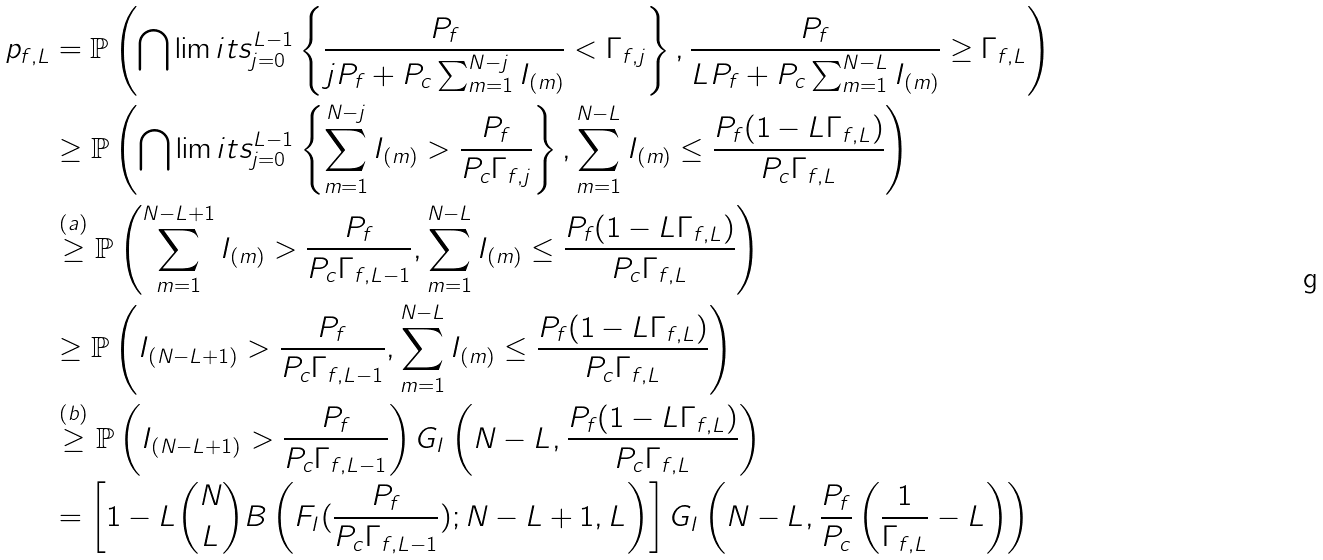Convert formula to latex. <formula><loc_0><loc_0><loc_500><loc_500>p _ { f , L } & = \mathbb { P } \left ( \bigcap \lim i t s _ { j = 0 } ^ { L - 1 } \left \{ \frac { P _ { f } } { j P _ { f } + P _ { c } \sum _ { m = 1 } ^ { N - j } I _ { ( m ) } } < \Gamma _ { f , j } \right \} , \frac { P _ { f } } { L P _ { f } + P _ { c } \sum _ { m = 1 } ^ { N - L } I _ { ( m ) } } \geq \Gamma _ { f , L } \right ) \\ & \geq \mathbb { P } \left ( \bigcap \lim i t s _ { j = 0 } ^ { L - 1 } \left \{ \sum _ { m = 1 } ^ { N - j } I _ { ( m ) } > \frac { P _ { f } } { P _ { c } \Gamma _ { f , j } } \right \} , \sum _ { m = 1 } ^ { N - L } I _ { ( m ) } \leq \frac { P _ { f } ( 1 - L \Gamma _ { f , L } ) } { P _ { c } \Gamma _ { f , L } } \right ) \\ & \stackrel { ( a ) } { \geq } \mathbb { P } \left ( \sum _ { m = 1 } ^ { N - L + 1 } I _ { ( m ) } > \frac { P _ { f } } { P _ { c } \Gamma _ { f , L - 1 } } , \sum _ { m = 1 } ^ { N - L } I _ { ( m ) } \leq \frac { P _ { f } ( 1 - L \Gamma _ { f , L } ) } { P _ { c } \Gamma _ { f , L } } \right ) \\ & \geq \mathbb { P } \left ( I _ { ( N - L + 1 ) } > \frac { P _ { f } } { P _ { c } \Gamma _ { f , L - 1 } } , \sum _ { m = 1 } ^ { N - L } I _ { ( m ) } \leq \frac { P _ { f } ( 1 - L \Gamma _ { f , L } ) } { P _ { c } \Gamma _ { f , L } } \right ) \\ & \stackrel { ( b ) } { \geq } \mathbb { P } \left ( I _ { ( N - L + 1 ) } > \frac { P _ { f } } { P _ { c } \Gamma _ { f , L - 1 } } \right ) G _ { I } \left ( N - L , \frac { P _ { f } ( 1 - L \Gamma _ { f , L } ) } { P _ { c } \Gamma _ { f , L } } \right ) \\ & = \left [ 1 - L \binom { N } { L } B \left ( F _ { I } ( \frac { P _ { f } } { P _ { c } \Gamma _ { f , L - 1 } } ) ; N - L + 1 , L \right ) \right ] G _ { I } \left ( N - L , \frac { P _ { f } } { P _ { c } } \left ( \frac { 1 } { \Gamma _ { f , L } } - L \right ) \right )</formula> 